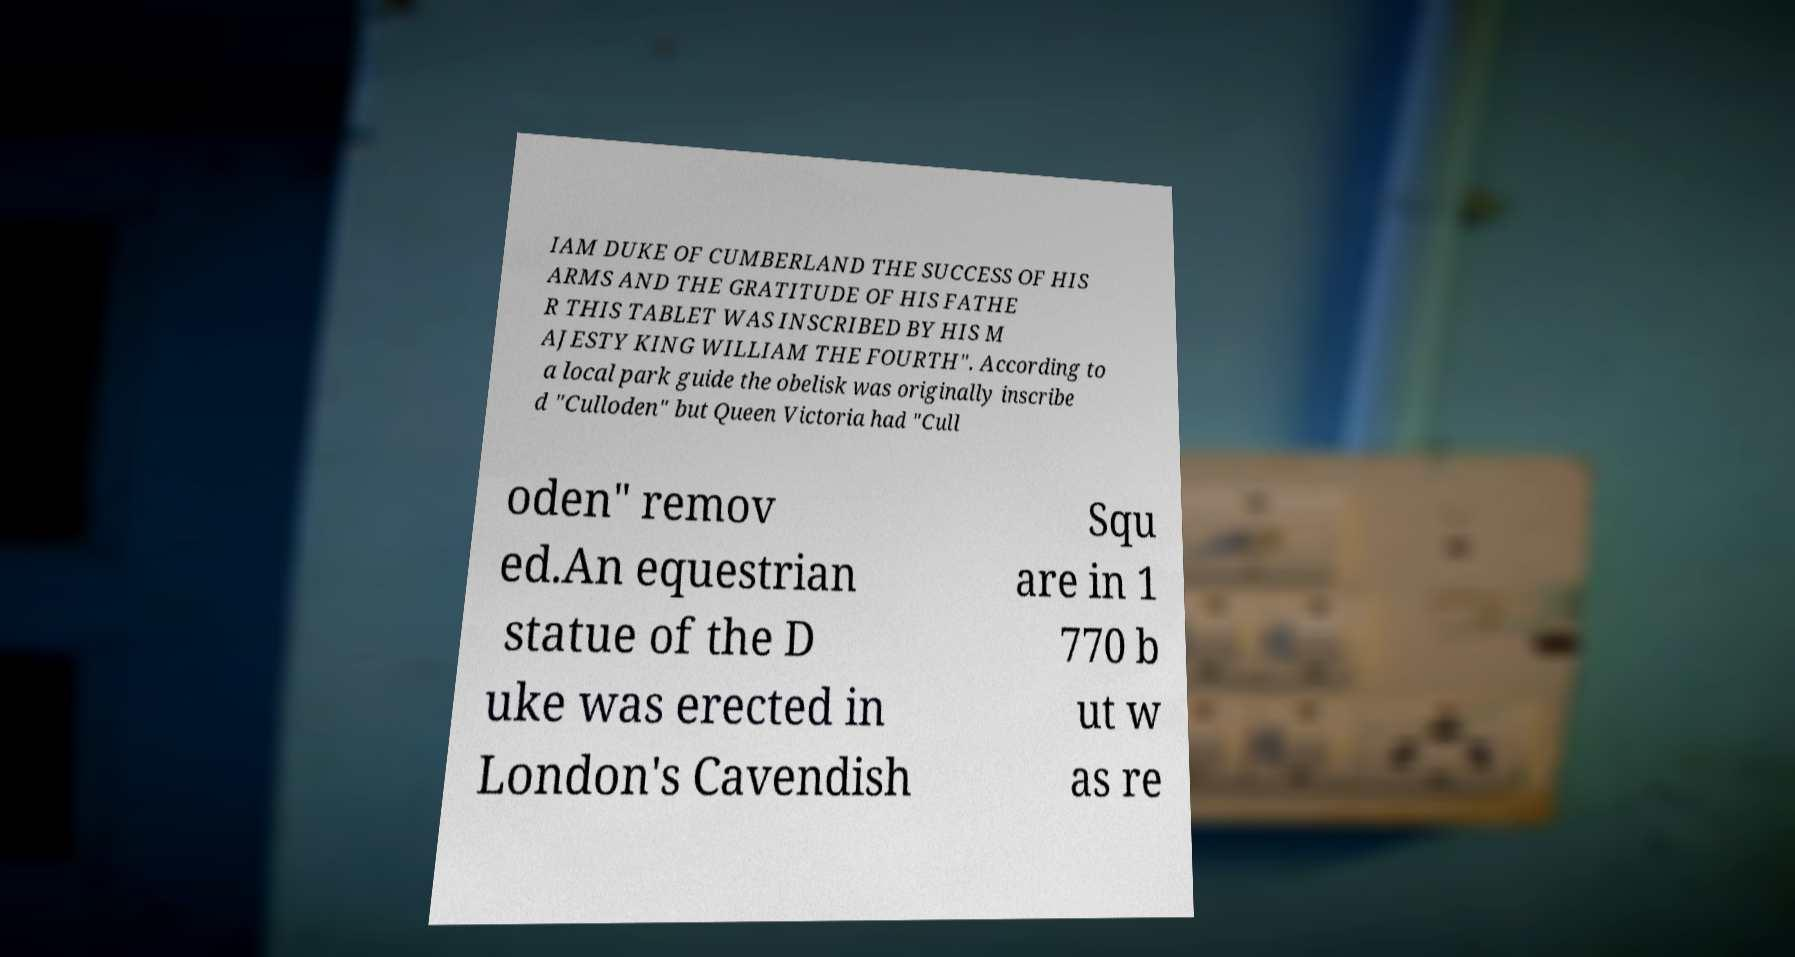Please read and relay the text visible in this image. What does it say? IAM DUKE OF CUMBERLAND THE SUCCESS OF HIS ARMS AND THE GRATITUDE OF HIS FATHE R THIS TABLET WAS INSCRIBED BY HIS M AJESTY KING WILLIAM THE FOURTH". According to a local park guide the obelisk was originally inscribe d "Culloden" but Queen Victoria had "Cull oden" remov ed.An equestrian statue of the D uke was erected in London's Cavendish Squ are in 1 770 b ut w as re 